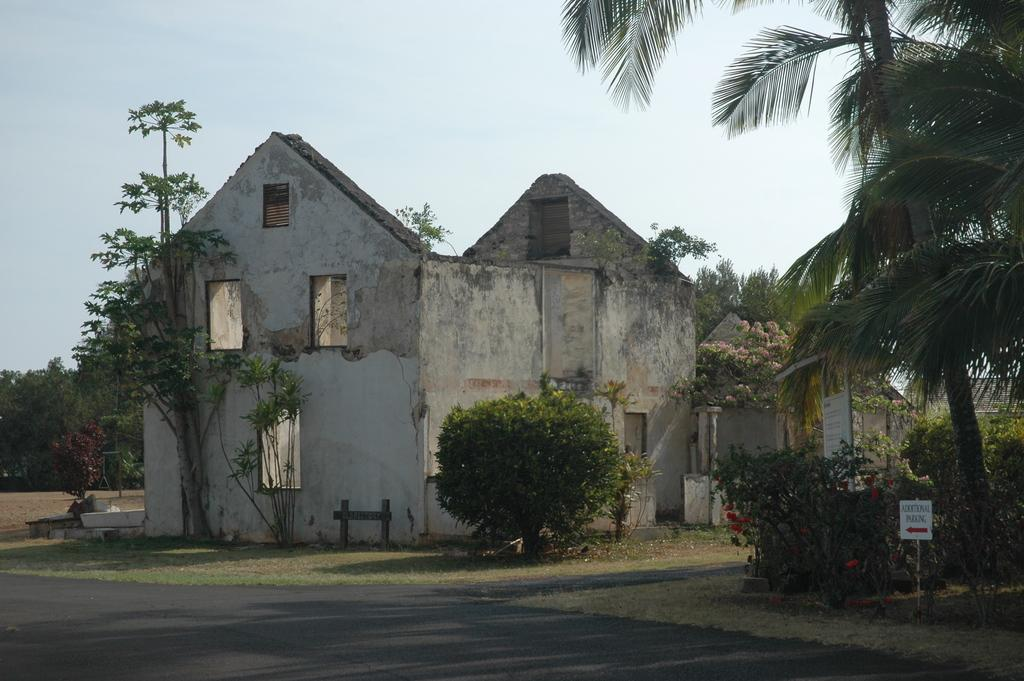What type of structures can be seen in the picture? There are houses in the picture. What is located at the bottom of the picture? There is a road at the bottom of the picture. Where are trees visible in the picture? There are trees on the left side and the right side of the picture. What can be seen in the sky in the picture? There are clouds in the sky. How many jellyfish can be seen swimming in the sky in the picture? There are no jellyfish present in the picture; it features houses, a road, trees, and clouds. 